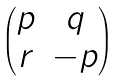<formula> <loc_0><loc_0><loc_500><loc_500>\begin{pmatrix} p & q \\ r & - p \end{pmatrix}</formula> 